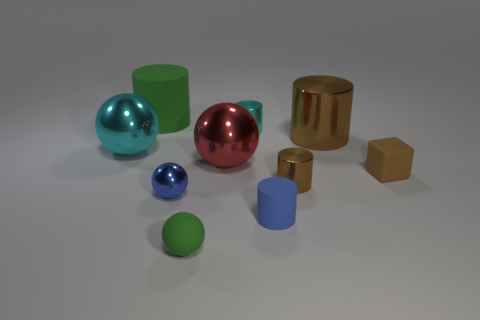Subtract all small metal balls. How many balls are left? 3 Subtract all green balls. How many balls are left? 3 Subtract all balls. How many objects are left? 6 Subtract all red cylinders. How many cyan spheres are left? 1 Add 9 large green cylinders. How many large green cylinders exist? 10 Subtract 0 yellow blocks. How many objects are left? 10 Subtract 2 spheres. How many spheres are left? 2 Subtract all green balls. Subtract all blue blocks. How many balls are left? 3 Subtract all tiny gray cubes. Subtract all brown things. How many objects are left? 7 Add 6 large green rubber things. How many large green rubber things are left? 7 